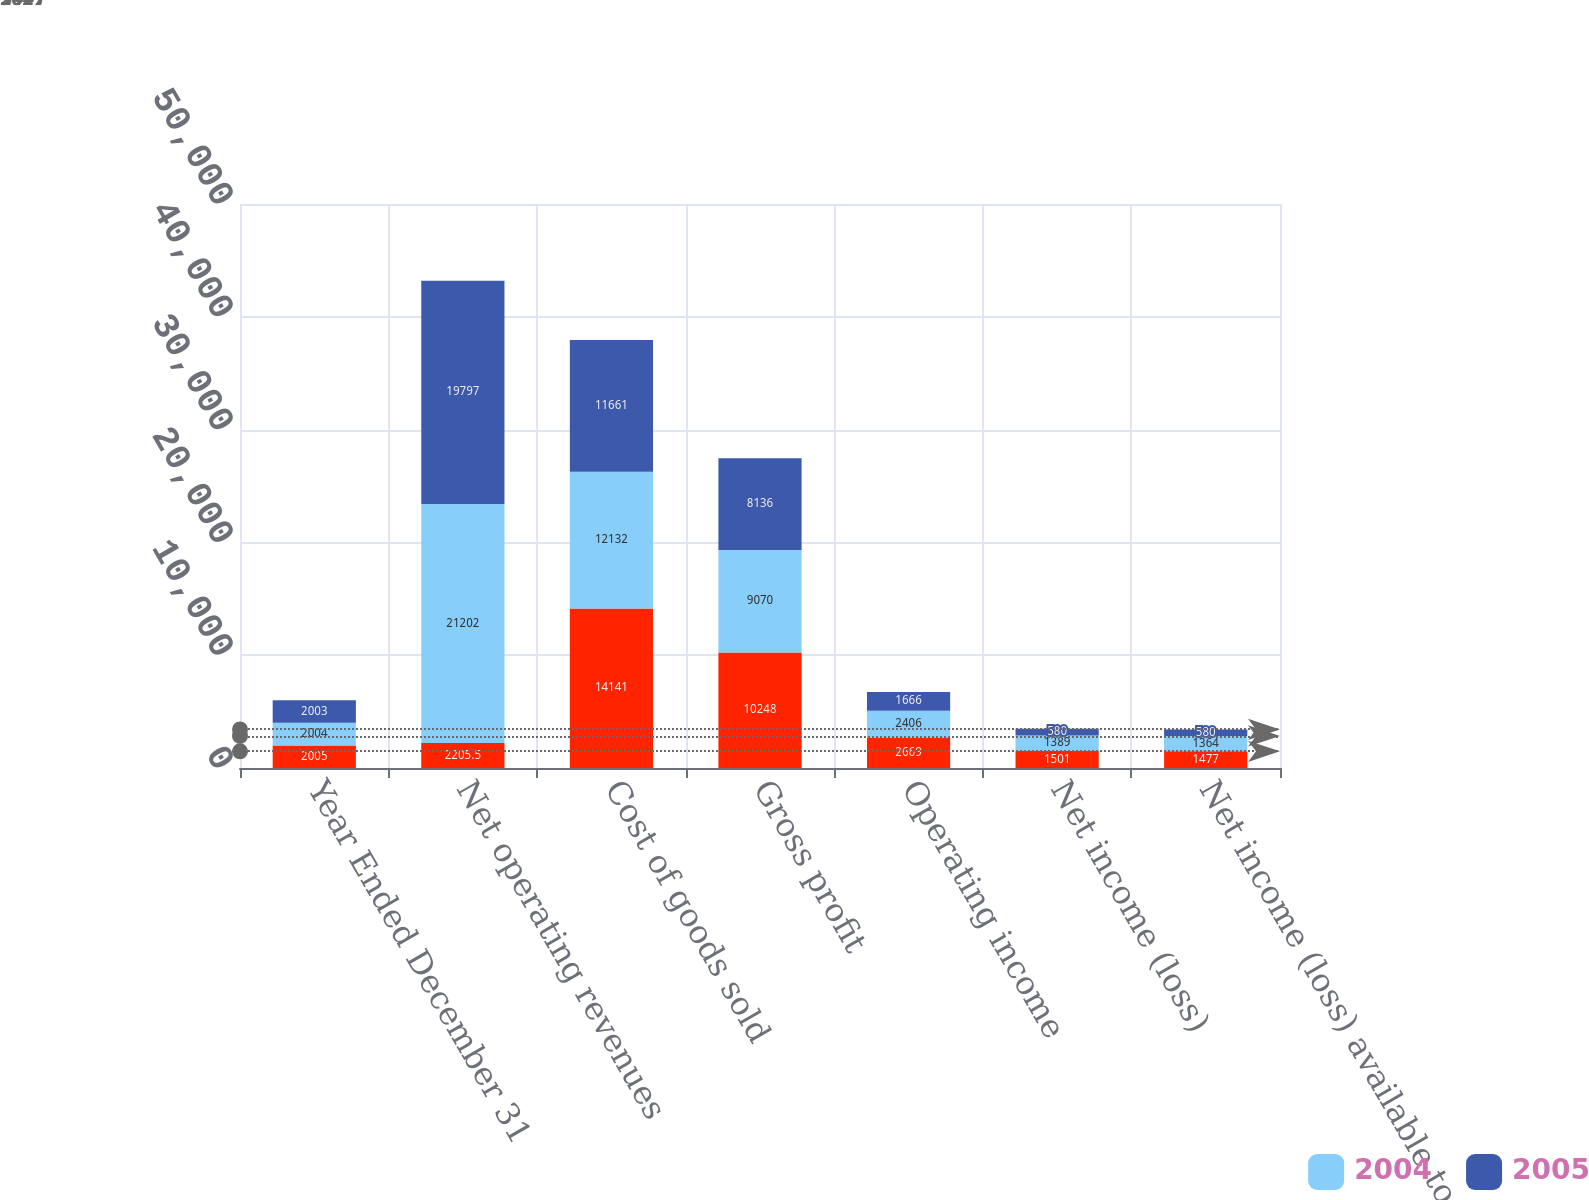Convert chart. <chart><loc_0><loc_0><loc_500><loc_500><stacked_bar_chart><ecel><fcel>Year Ended December 31<fcel>Net operating revenues<fcel>Cost of goods sold<fcel>Gross profit<fcel>Operating income<fcel>Net income (loss)<fcel>Net income (loss) available to<nl><fcel>nan<fcel>2005<fcel>2205.5<fcel>14141<fcel>10248<fcel>2669<fcel>1501<fcel>1477<nl><fcel>2004<fcel>2004<fcel>21202<fcel>12132<fcel>9070<fcel>2406<fcel>1389<fcel>1364<nl><fcel>2005<fcel>2003<fcel>19797<fcel>11661<fcel>8136<fcel>1666<fcel>580<fcel>580<nl></chart> 